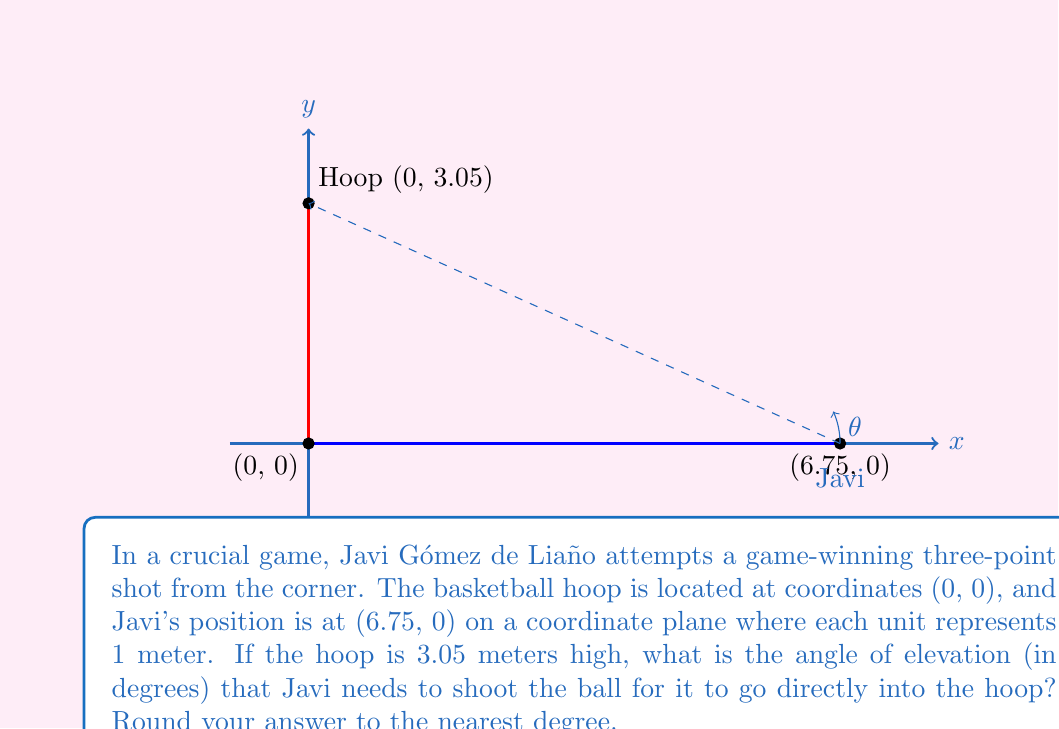Help me with this question. To solve this problem, we'll use trigonometry in the context of coordinate geometry. Here's a step-by-step solution:

1) First, let's identify the right triangle formed by Javi's position, the hoop, and the ground:
   - The base of the triangle is 6.75 meters (Javi's x-coordinate)
   - The height of the triangle is 3.05 meters (height of the hoop)

2) We need to find the angle of elevation, which is the angle between the horizontal line and the line of sight to the hoop.

3) In a right triangle, the tangent of an angle is the ratio of the opposite side to the adjacent side:

   $$\tan(\theta) = \frac{\text{opposite}}{\text{adjacent}} = \frac{\text{height}}{\text{base}}$$

4) Substituting our values:

   $$\tan(\theta) = \frac{3.05}{6.75}$$

5) To find the angle, we need to use the inverse tangent (arctan or $\tan^{-1}$):

   $$\theta = \tan^{-1}\left(\frac{3.05}{6.75}\right)$$

6) Using a calculator or computer:

   $$\theta \approx 24.35^\circ$$

7) Rounding to the nearest degree:

   $$\theta \approx 24^\circ$$

Therefore, Javi needs to shoot at an angle of approximately 24 degrees above the horizontal to make the three-point shot.
Answer: $24^\circ$ 